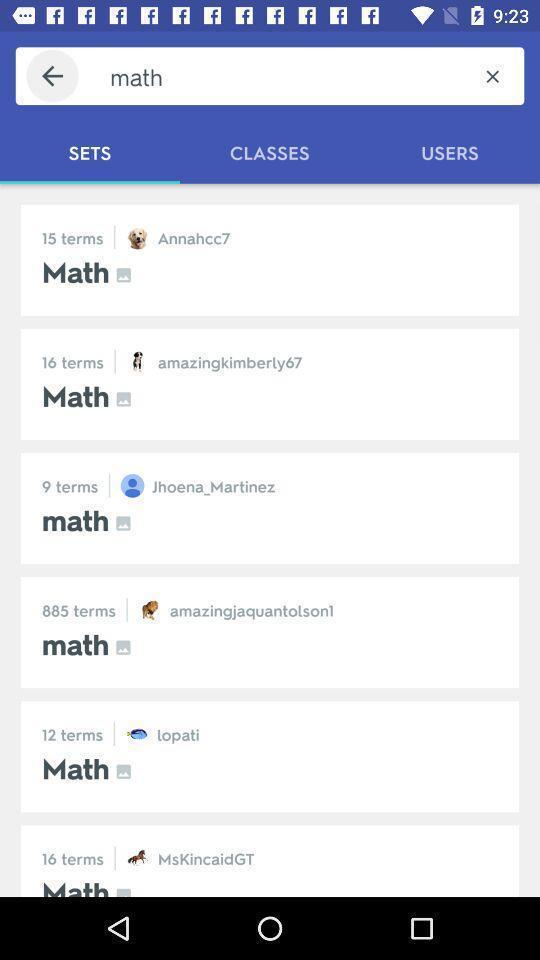Summarize the main components in this picture. Search bar showing in this page. 